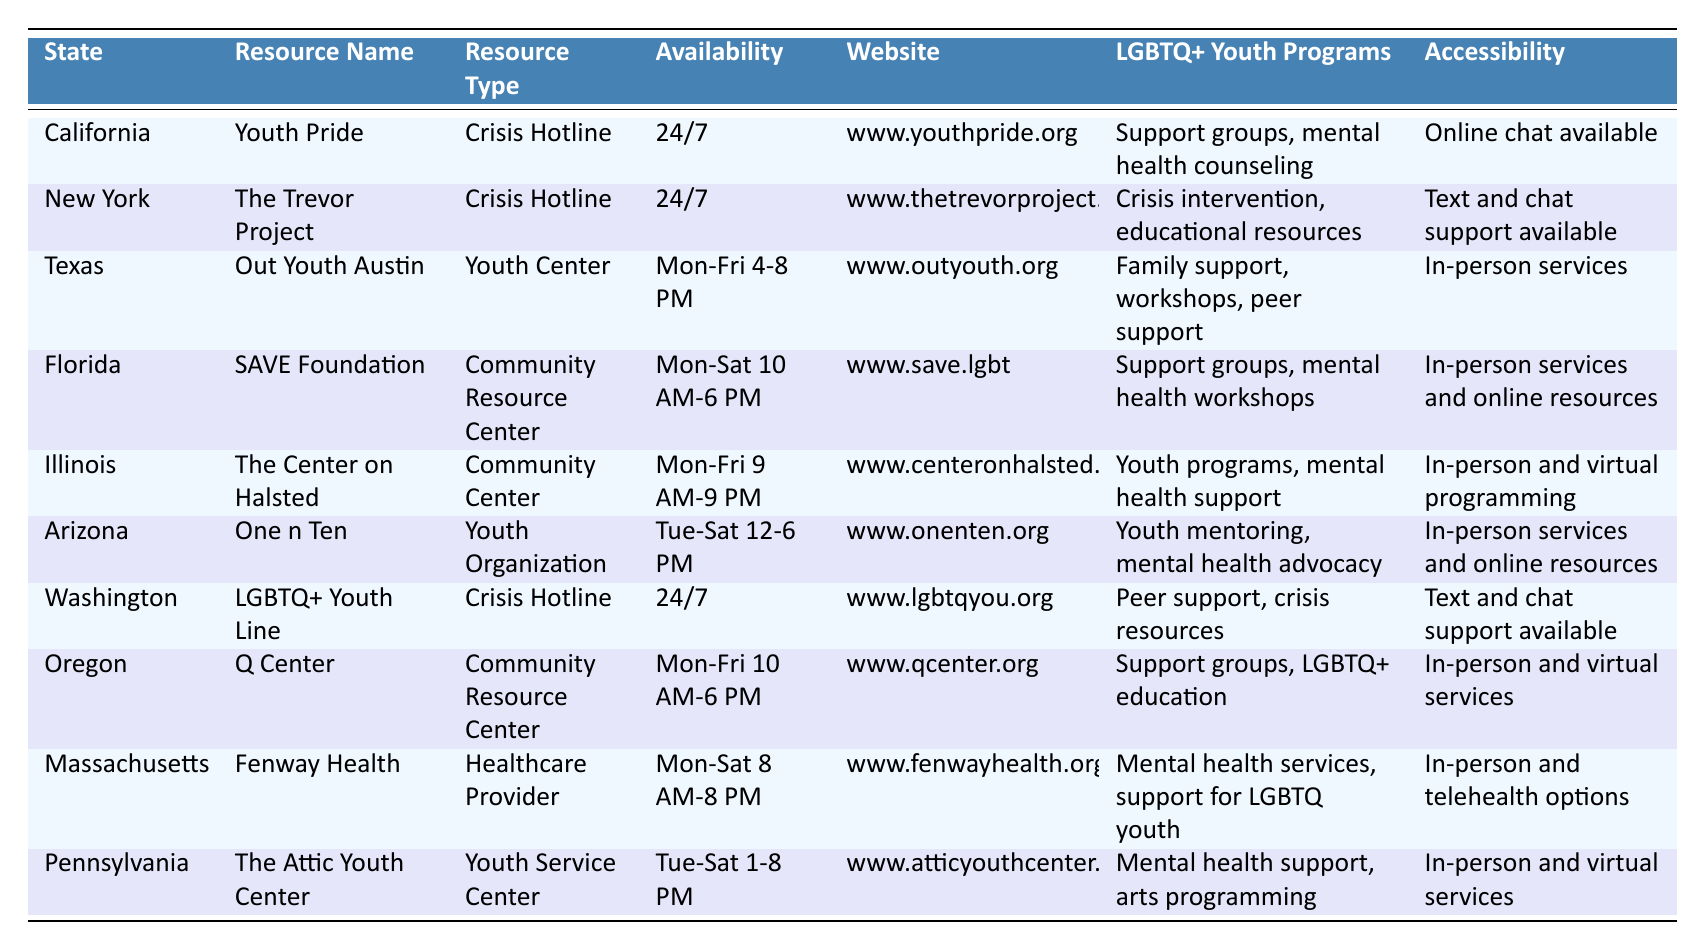What resource in California is available 24/7? The table indicates that "Youth Pride" in California is a crisis hotline that operates 24/7.
Answer: Youth Pride Which state has a community resource center that operates on Saturdays? The table shows that the "SAVE Foundation" in Florida is a community resource center that operates from Monday to Saturday, specifically mentioning Saturday availability.
Answer: Florida How many states have crisis hotlines available 24/7? In the table, the following crisis hotlines are available 24/7: "Youth Pride" (California), "The Trevor Project" (New York), and "LGBTQ+ Youth Line" (Washington). This totals three states with 24/7 crisis hotlines.
Answer: 3 Is there a resource in New York that provides mental health counseling? According to the table, "The Trevor Project" in New York offers crisis intervention and educational resources, but it doesn't specifically list mental health counseling, making the answer "no."
Answer: No Which resources provide both in-person services and online options? Referring to the table, "Fenway Health" (Massachusetts), "The Center on Halsted" (Illinois), "Q Center" (Oregon), and "One n Ten" (Arizona) all have in-person services and also provide online options. Thus, there are four resources meeting this criterion.
Answer: 4 What is the operational time for "The Attic Youth Center" in Pennsylvania? The table states that "The Attic Youth Center" in Pennsylvania operates from Tuesday to Saturday, 1 PM to 8 PM.
Answer: Tue-Sat 1-8 PM Which state's resource is a youth center and what programs does it offer? The table shows that "Out Youth Austin" in Texas is identified as a youth center, offering family support, workshops, and peer support programs.
Answer: Texas; family support, workshops, peer support How many resources provide LGBTQ youth programs like support groups? Analyzing the table, the following resources provide support groups: "Youth Pride" (California), "SAVE Foundation" (Florida), "The Center on Halsted" (Illinois), "Q Center" (Oregon), and "Fenway Health" (Massachusetts). This results in five resources.
Answer: 5 Does the "Fenway Health" offer telehealth options? The table explicitly mentions that "Fenway Health" in Massachusetts provides in-person and telehealth options for LGBTQ youth support. Therefore, the answer is "yes."
Answer: Yes Which crisis hotline in California offers online chat support? According to the table, "Youth Pride" in California is a crisis hotline that features online chat support, confirming that it provides this service.
Answer: Youth Pride 